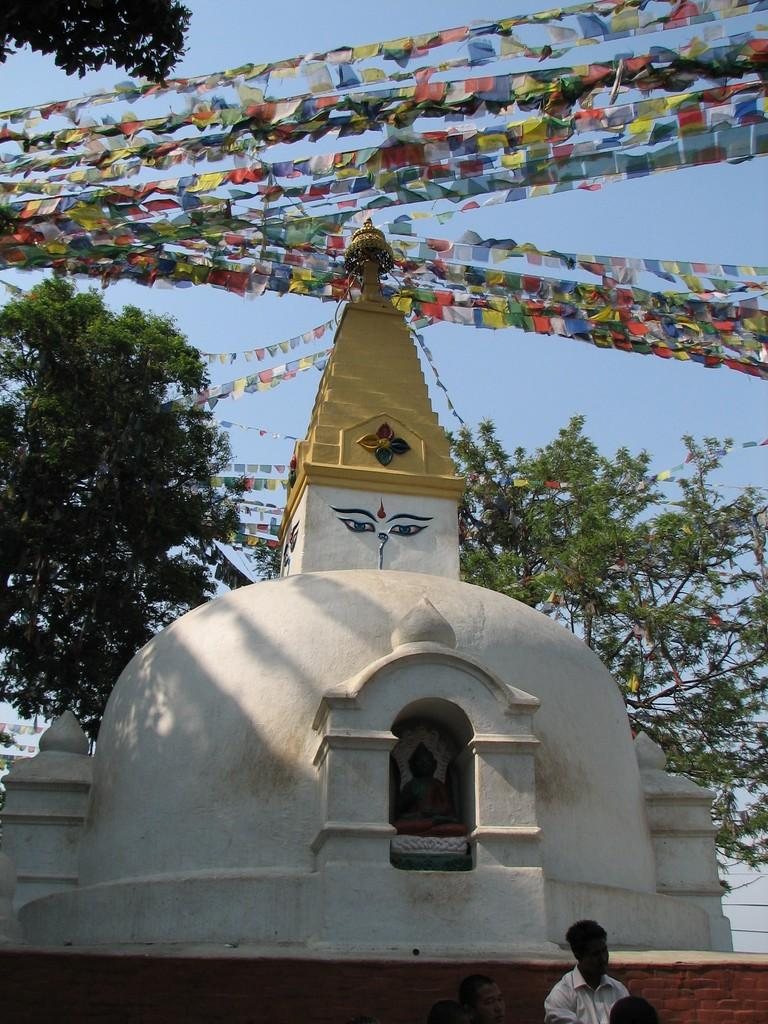What type of structure is in the image? There is a temple in the image. Can you describe the person in the image? A person is present at the bottom of the image. What can be seen in the sky in the image? The sky is visible in the image. What type of vegetation is present in the image? Trees are present in the image. What is attached to the roof of the temple? Colorful papers are attached to the roof of the temple. What direction is the crowd moving in the image? There is no crowd present in the image. What type of fuel is being used by the temple in the image? The image does not provide information about the temple's fuel source. 